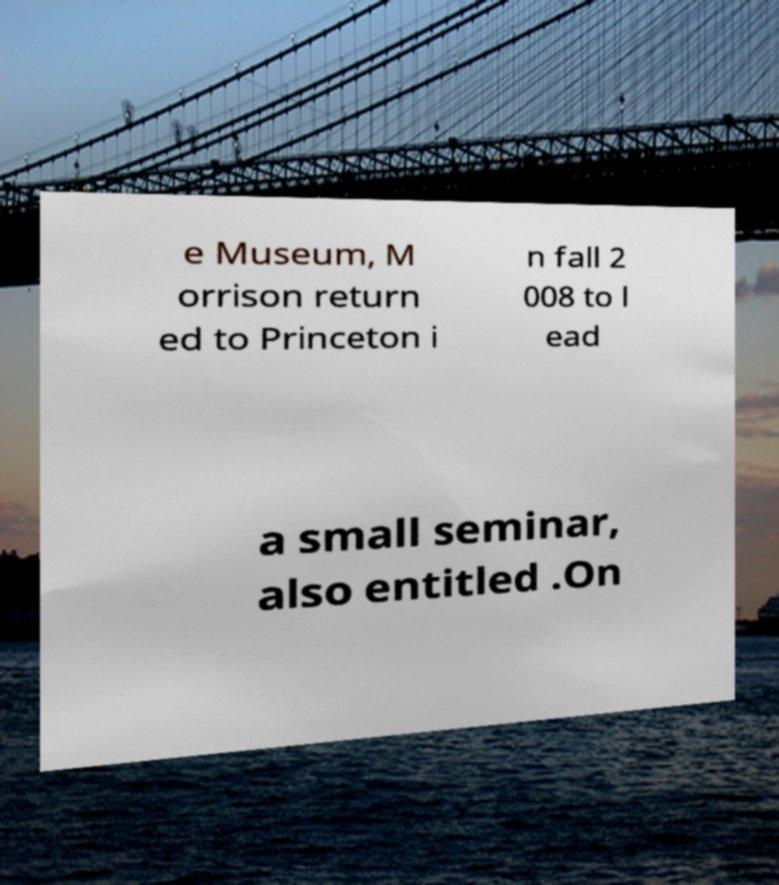Please identify and transcribe the text found in this image. e Museum, M orrison return ed to Princeton i n fall 2 008 to l ead a small seminar, also entitled .On 